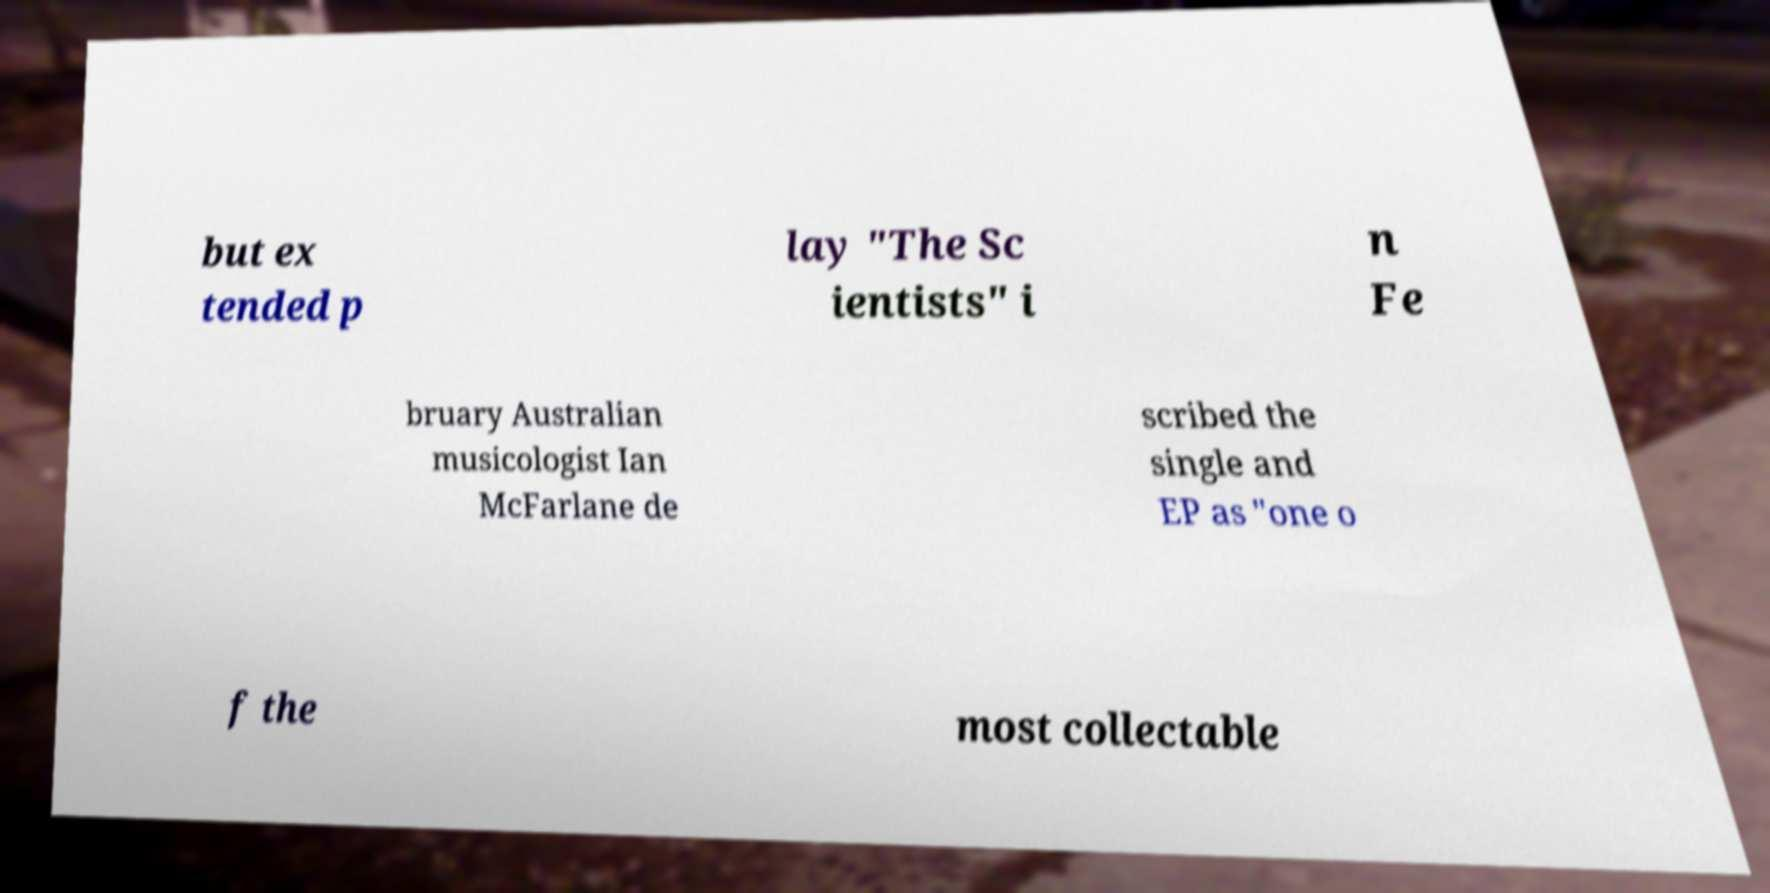Please read and relay the text visible in this image. What does it say? but ex tended p lay "The Sc ientists" i n Fe bruary Australian musicologist Ian McFarlane de scribed the single and EP as "one o f the most collectable 